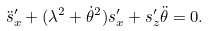Convert formula to latex. <formula><loc_0><loc_0><loc_500><loc_500>\ddot { s } ^ { \prime } _ { x } + ( \lambda ^ { 2 } + \dot { \theta } ^ { 2 } ) s ^ { \prime } _ { x } + s ^ { \prime } _ { z } \ddot { \theta } = 0 .</formula> 